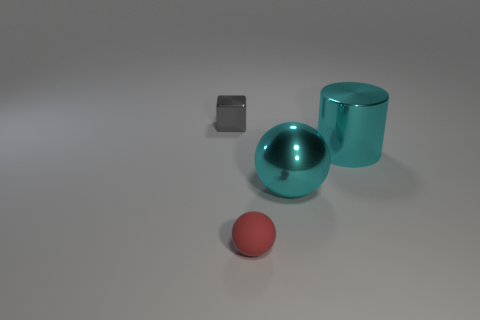Add 4 brown rubber spheres. How many objects exist? 8 Subtract all blocks. How many objects are left? 3 Add 1 red rubber things. How many red rubber things are left? 2 Add 3 gray objects. How many gray objects exist? 4 Subtract 1 red balls. How many objects are left? 3 Subtract all red things. Subtract all cyan metal cylinders. How many objects are left? 2 